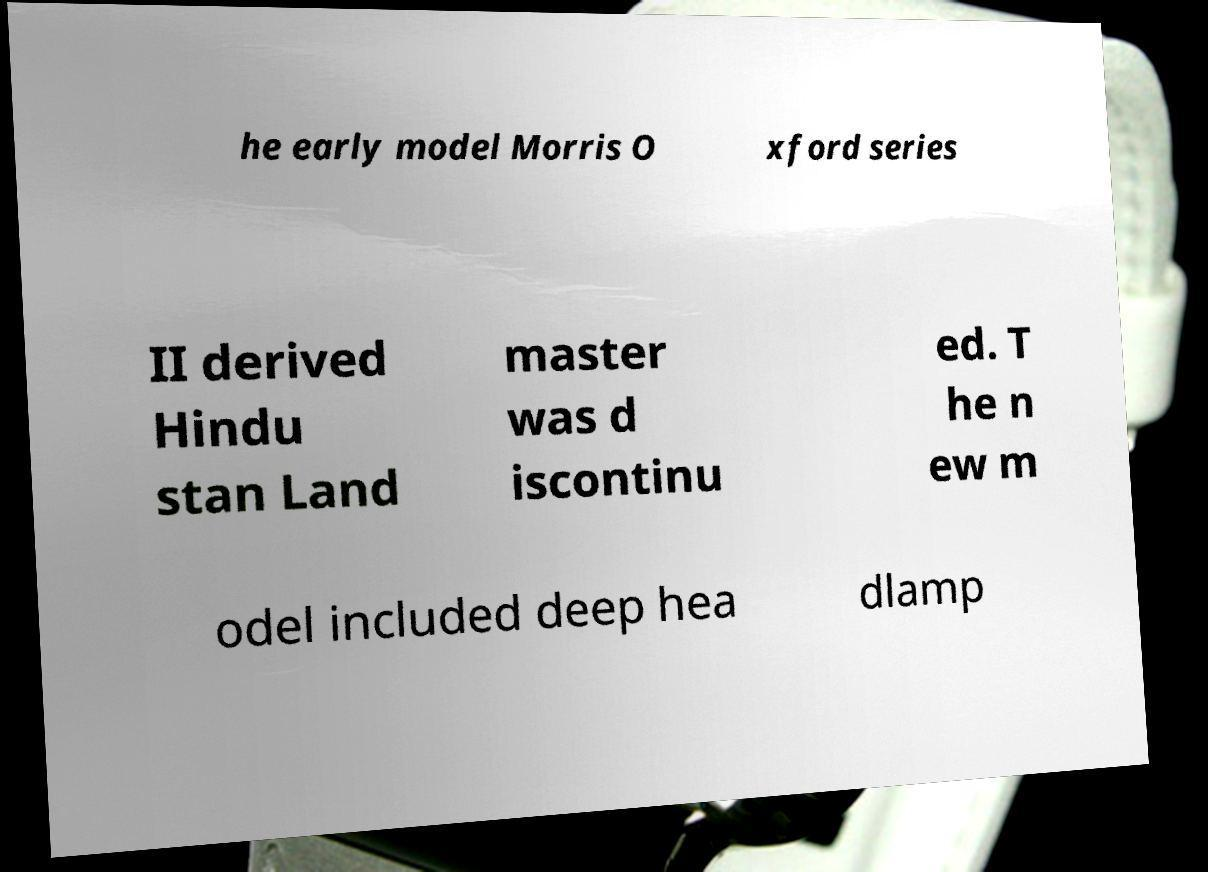Can you read and provide the text displayed in the image?This photo seems to have some interesting text. Can you extract and type it out for me? he early model Morris O xford series II derived Hindu stan Land master was d iscontinu ed. T he n ew m odel included deep hea dlamp 